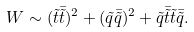<formula> <loc_0><loc_0><loc_500><loc_500>W \sim ( \tilde { t } \bar { \tilde { t } } ) ^ { 2 } + ( \tilde { q } \bar { \tilde { q } } ) ^ { 2 } + \tilde { q } \bar { \tilde { t } } \tilde { t } \bar { \tilde { q } } .</formula> 